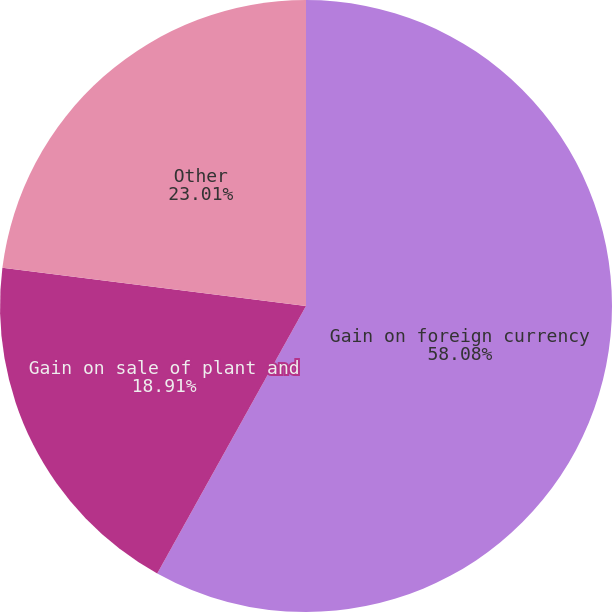<chart> <loc_0><loc_0><loc_500><loc_500><pie_chart><fcel>Gain on foreign currency<fcel>Gain on sale of plant and<fcel>Other<nl><fcel>58.08%<fcel>18.91%<fcel>23.01%<nl></chart> 